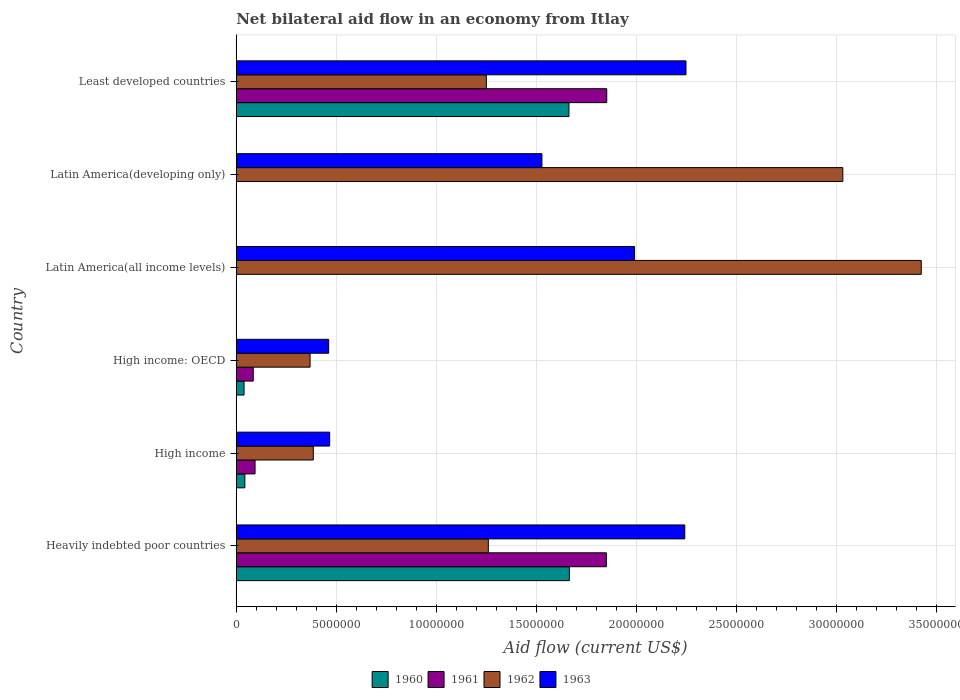Are the number of bars on each tick of the Y-axis equal?
Your response must be concise. No. How many bars are there on the 3rd tick from the top?
Your answer should be very brief. 2. How many bars are there on the 3rd tick from the bottom?
Your response must be concise. 4. What is the label of the 1st group of bars from the top?
Keep it short and to the point. Least developed countries. In how many cases, is the number of bars for a given country not equal to the number of legend labels?
Your answer should be compact. 2. What is the net bilateral aid flow in 1962 in Heavily indebted poor countries?
Offer a very short reply. 1.26e+07. Across all countries, what is the maximum net bilateral aid flow in 1963?
Your answer should be very brief. 2.25e+07. In which country was the net bilateral aid flow in 1963 maximum?
Provide a short and direct response. Least developed countries. What is the total net bilateral aid flow in 1960 in the graph?
Ensure brevity in your answer.  3.41e+07. What is the difference between the net bilateral aid flow in 1962 in High income: OECD and that in Latin America(all income levels)?
Your answer should be very brief. -3.06e+07. What is the difference between the net bilateral aid flow in 1961 in High income and the net bilateral aid flow in 1960 in Latin America(developing only)?
Ensure brevity in your answer.  9.40e+05. What is the average net bilateral aid flow in 1961 per country?
Provide a succinct answer. 6.47e+06. What is the difference between the net bilateral aid flow in 1962 and net bilateral aid flow in 1960 in High income: OECD?
Ensure brevity in your answer.  3.30e+06. In how many countries, is the net bilateral aid flow in 1961 greater than 14000000 US$?
Ensure brevity in your answer.  2. What is the ratio of the net bilateral aid flow in 1963 in Heavily indebted poor countries to that in Least developed countries?
Your answer should be compact. 1. Is the net bilateral aid flow in 1962 in Latin America(all income levels) less than that in Least developed countries?
Ensure brevity in your answer.  No. What is the difference between the highest and the lowest net bilateral aid flow in 1960?
Keep it short and to the point. 1.66e+07. In how many countries, is the net bilateral aid flow in 1962 greater than the average net bilateral aid flow in 1962 taken over all countries?
Make the answer very short. 2. Is it the case that in every country, the sum of the net bilateral aid flow in 1962 and net bilateral aid flow in 1961 is greater than the sum of net bilateral aid flow in 1963 and net bilateral aid flow in 1960?
Keep it short and to the point. No. Does the graph contain grids?
Make the answer very short. Yes. How many legend labels are there?
Provide a short and direct response. 4. What is the title of the graph?
Make the answer very short. Net bilateral aid flow in an economy from Itlay. What is the Aid flow (current US$) of 1960 in Heavily indebted poor countries?
Offer a very short reply. 1.66e+07. What is the Aid flow (current US$) of 1961 in Heavily indebted poor countries?
Provide a short and direct response. 1.85e+07. What is the Aid flow (current US$) in 1962 in Heavily indebted poor countries?
Offer a terse response. 1.26e+07. What is the Aid flow (current US$) in 1963 in Heavily indebted poor countries?
Provide a short and direct response. 2.24e+07. What is the Aid flow (current US$) in 1961 in High income?
Provide a short and direct response. 9.40e+05. What is the Aid flow (current US$) of 1962 in High income?
Your answer should be compact. 3.85e+06. What is the Aid flow (current US$) of 1963 in High income?
Your response must be concise. 4.67e+06. What is the Aid flow (current US$) of 1960 in High income: OECD?
Ensure brevity in your answer.  3.90e+05. What is the Aid flow (current US$) in 1961 in High income: OECD?
Offer a very short reply. 8.50e+05. What is the Aid flow (current US$) in 1962 in High income: OECD?
Keep it short and to the point. 3.69e+06. What is the Aid flow (current US$) of 1963 in High income: OECD?
Provide a succinct answer. 4.62e+06. What is the Aid flow (current US$) of 1960 in Latin America(all income levels)?
Provide a succinct answer. 0. What is the Aid flow (current US$) of 1961 in Latin America(all income levels)?
Provide a short and direct response. 0. What is the Aid flow (current US$) of 1962 in Latin America(all income levels)?
Provide a succinct answer. 3.42e+07. What is the Aid flow (current US$) in 1963 in Latin America(all income levels)?
Offer a terse response. 1.99e+07. What is the Aid flow (current US$) of 1962 in Latin America(developing only)?
Keep it short and to the point. 3.03e+07. What is the Aid flow (current US$) in 1963 in Latin America(developing only)?
Your answer should be very brief. 1.53e+07. What is the Aid flow (current US$) of 1960 in Least developed countries?
Your response must be concise. 1.66e+07. What is the Aid flow (current US$) in 1961 in Least developed countries?
Give a very brief answer. 1.85e+07. What is the Aid flow (current US$) of 1962 in Least developed countries?
Your response must be concise. 1.25e+07. What is the Aid flow (current US$) of 1963 in Least developed countries?
Ensure brevity in your answer.  2.25e+07. Across all countries, what is the maximum Aid flow (current US$) of 1960?
Offer a very short reply. 1.66e+07. Across all countries, what is the maximum Aid flow (current US$) in 1961?
Offer a terse response. 1.85e+07. Across all countries, what is the maximum Aid flow (current US$) of 1962?
Your response must be concise. 3.42e+07. Across all countries, what is the maximum Aid flow (current US$) of 1963?
Your answer should be compact. 2.25e+07. Across all countries, what is the minimum Aid flow (current US$) of 1960?
Provide a short and direct response. 0. Across all countries, what is the minimum Aid flow (current US$) of 1961?
Offer a very short reply. 0. Across all countries, what is the minimum Aid flow (current US$) of 1962?
Provide a short and direct response. 3.69e+06. Across all countries, what is the minimum Aid flow (current US$) of 1963?
Provide a short and direct response. 4.62e+06. What is the total Aid flow (current US$) of 1960 in the graph?
Your answer should be compact. 3.41e+07. What is the total Aid flow (current US$) of 1961 in the graph?
Offer a very short reply. 3.88e+07. What is the total Aid flow (current US$) in 1962 in the graph?
Offer a terse response. 9.72e+07. What is the total Aid flow (current US$) in 1963 in the graph?
Offer a terse response. 8.94e+07. What is the difference between the Aid flow (current US$) of 1960 in Heavily indebted poor countries and that in High income?
Provide a short and direct response. 1.62e+07. What is the difference between the Aid flow (current US$) of 1961 in Heavily indebted poor countries and that in High income?
Keep it short and to the point. 1.76e+07. What is the difference between the Aid flow (current US$) in 1962 in Heavily indebted poor countries and that in High income?
Your answer should be compact. 8.75e+06. What is the difference between the Aid flow (current US$) of 1963 in Heavily indebted poor countries and that in High income?
Give a very brief answer. 1.78e+07. What is the difference between the Aid flow (current US$) of 1960 in Heavily indebted poor countries and that in High income: OECD?
Provide a succinct answer. 1.63e+07. What is the difference between the Aid flow (current US$) of 1961 in Heavily indebted poor countries and that in High income: OECD?
Ensure brevity in your answer.  1.76e+07. What is the difference between the Aid flow (current US$) in 1962 in Heavily indebted poor countries and that in High income: OECD?
Your answer should be very brief. 8.91e+06. What is the difference between the Aid flow (current US$) in 1963 in Heavily indebted poor countries and that in High income: OECD?
Your response must be concise. 1.78e+07. What is the difference between the Aid flow (current US$) of 1962 in Heavily indebted poor countries and that in Latin America(all income levels)?
Make the answer very short. -2.16e+07. What is the difference between the Aid flow (current US$) of 1963 in Heavily indebted poor countries and that in Latin America(all income levels)?
Ensure brevity in your answer.  2.51e+06. What is the difference between the Aid flow (current US$) in 1962 in Heavily indebted poor countries and that in Latin America(developing only)?
Ensure brevity in your answer.  -1.77e+07. What is the difference between the Aid flow (current US$) of 1963 in Heavily indebted poor countries and that in Latin America(developing only)?
Your answer should be very brief. 7.14e+06. What is the difference between the Aid flow (current US$) in 1960 in Heavily indebted poor countries and that in Least developed countries?
Offer a terse response. 2.00e+04. What is the difference between the Aid flow (current US$) in 1961 in Heavily indebted poor countries and that in Least developed countries?
Provide a short and direct response. -2.00e+04. What is the difference between the Aid flow (current US$) in 1962 in Heavily indebted poor countries and that in Least developed countries?
Offer a very short reply. 1.00e+05. What is the difference between the Aid flow (current US$) in 1963 in Heavily indebted poor countries and that in Least developed countries?
Your answer should be very brief. -6.00e+04. What is the difference between the Aid flow (current US$) in 1960 in High income and that in High income: OECD?
Make the answer very short. 4.00e+04. What is the difference between the Aid flow (current US$) of 1961 in High income and that in High income: OECD?
Offer a terse response. 9.00e+04. What is the difference between the Aid flow (current US$) of 1963 in High income and that in High income: OECD?
Keep it short and to the point. 5.00e+04. What is the difference between the Aid flow (current US$) of 1962 in High income and that in Latin America(all income levels)?
Offer a terse response. -3.04e+07. What is the difference between the Aid flow (current US$) of 1963 in High income and that in Latin America(all income levels)?
Ensure brevity in your answer.  -1.52e+07. What is the difference between the Aid flow (current US$) in 1962 in High income and that in Latin America(developing only)?
Your answer should be very brief. -2.65e+07. What is the difference between the Aid flow (current US$) in 1963 in High income and that in Latin America(developing only)?
Keep it short and to the point. -1.06e+07. What is the difference between the Aid flow (current US$) in 1960 in High income and that in Least developed countries?
Provide a succinct answer. -1.62e+07. What is the difference between the Aid flow (current US$) in 1961 in High income and that in Least developed countries?
Offer a very short reply. -1.76e+07. What is the difference between the Aid flow (current US$) of 1962 in High income and that in Least developed countries?
Ensure brevity in your answer.  -8.65e+06. What is the difference between the Aid flow (current US$) in 1963 in High income and that in Least developed countries?
Provide a succinct answer. -1.78e+07. What is the difference between the Aid flow (current US$) in 1962 in High income: OECD and that in Latin America(all income levels)?
Make the answer very short. -3.06e+07. What is the difference between the Aid flow (current US$) in 1963 in High income: OECD and that in Latin America(all income levels)?
Ensure brevity in your answer.  -1.53e+07. What is the difference between the Aid flow (current US$) in 1962 in High income: OECD and that in Latin America(developing only)?
Offer a very short reply. -2.66e+07. What is the difference between the Aid flow (current US$) in 1963 in High income: OECD and that in Latin America(developing only)?
Ensure brevity in your answer.  -1.07e+07. What is the difference between the Aid flow (current US$) of 1960 in High income: OECD and that in Least developed countries?
Ensure brevity in your answer.  -1.62e+07. What is the difference between the Aid flow (current US$) in 1961 in High income: OECD and that in Least developed countries?
Offer a very short reply. -1.77e+07. What is the difference between the Aid flow (current US$) in 1962 in High income: OECD and that in Least developed countries?
Provide a succinct answer. -8.81e+06. What is the difference between the Aid flow (current US$) in 1963 in High income: OECD and that in Least developed countries?
Provide a succinct answer. -1.79e+07. What is the difference between the Aid flow (current US$) of 1962 in Latin America(all income levels) and that in Latin America(developing only)?
Provide a short and direct response. 3.92e+06. What is the difference between the Aid flow (current US$) in 1963 in Latin America(all income levels) and that in Latin America(developing only)?
Offer a terse response. 4.63e+06. What is the difference between the Aid flow (current US$) of 1962 in Latin America(all income levels) and that in Least developed countries?
Provide a succinct answer. 2.17e+07. What is the difference between the Aid flow (current US$) in 1963 in Latin America(all income levels) and that in Least developed countries?
Your answer should be compact. -2.57e+06. What is the difference between the Aid flow (current US$) in 1962 in Latin America(developing only) and that in Least developed countries?
Make the answer very short. 1.78e+07. What is the difference between the Aid flow (current US$) of 1963 in Latin America(developing only) and that in Least developed countries?
Provide a succinct answer. -7.20e+06. What is the difference between the Aid flow (current US$) in 1960 in Heavily indebted poor countries and the Aid flow (current US$) in 1961 in High income?
Offer a terse response. 1.57e+07. What is the difference between the Aid flow (current US$) in 1960 in Heavily indebted poor countries and the Aid flow (current US$) in 1962 in High income?
Your response must be concise. 1.28e+07. What is the difference between the Aid flow (current US$) in 1960 in Heavily indebted poor countries and the Aid flow (current US$) in 1963 in High income?
Make the answer very short. 1.20e+07. What is the difference between the Aid flow (current US$) in 1961 in Heavily indebted poor countries and the Aid flow (current US$) in 1962 in High income?
Give a very brief answer. 1.46e+07. What is the difference between the Aid flow (current US$) of 1961 in Heavily indebted poor countries and the Aid flow (current US$) of 1963 in High income?
Make the answer very short. 1.38e+07. What is the difference between the Aid flow (current US$) of 1962 in Heavily indebted poor countries and the Aid flow (current US$) of 1963 in High income?
Give a very brief answer. 7.93e+06. What is the difference between the Aid flow (current US$) of 1960 in Heavily indebted poor countries and the Aid flow (current US$) of 1961 in High income: OECD?
Make the answer very short. 1.58e+07. What is the difference between the Aid flow (current US$) of 1960 in Heavily indebted poor countries and the Aid flow (current US$) of 1962 in High income: OECD?
Your answer should be compact. 1.30e+07. What is the difference between the Aid flow (current US$) in 1960 in Heavily indebted poor countries and the Aid flow (current US$) in 1963 in High income: OECD?
Provide a short and direct response. 1.20e+07. What is the difference between the Aid flow (current US$) of 1961 in Heavily indebted poor countries and the Aid flow (current US$) of 1962 in High income: OECD?
Give a very brief answer. 1.48e+07. What is the difference between the Aid flow (current US$) of 1961 in Heavily indebted poor countries and the Aid flow (current US$) of 1963 in High income: OECD?
Your answer should be very brief. 1.39e+07. What is the difference between the Aid flow (current US$) of 1962 in Heavily indebted poor countries and the Aid flow (current US$) of 1963 in High income: OECD?
Offer a very short reply. 7.98e+06. What is the difference between the Aid flow (current US$) in 1960 in Heavily indebted poor countries and the Aid flow (current US$) in 1962 in Latin America(all income levels)?
Offer a terse response. -1.76e+07. What is the difference between the Aid flow (current US$) of 1960 in Heavily indebted poor countries and the Aid flow (current US$) of 1963 in Latin America(all income levels)?
Provide a succinct answer. -3.26e+06. What is the difference between the Aid flow (current US$) of 1961 in Heavily indebted poor countries and the Aid flow (current US$) of 1962 in Latin America(all income levels)?
Ensure brevity in your answer.  -1.57e+07. What is the difference between the Aid flow (current US$) in 1961 in Heavily indebted poor countries and the Aid flow (current US$) in 1963 in Latin America(all income levels)?
Keep it short and to the point. -1.41e+06. What is the difference between the Aid flow (current US$) of 1962 in Heavily indebted poor countries and the Aid flow (current US$) of 1963 in Latin America(all income levels)?
Your answer should be compact. -7.31e+06. What is the difference between the Aid flow (current US$) of 1960 in Heavily indebted poor countries and the Aid flow (current US$) of 1962 in Latin America(developing only)?
Your response must be concise. -1.37e+07. What is the difference between the Aid flow (current US$) in 1960 in Heavily indebted poor countries and the Aid flow (current US$) in 1963 in Latin America(developing only)?
Make the answer very short. 1.37e+06. What is the difference between the Aid flow (current US$) of 1961 in Heavily indebted poor countries and the Aid flow (current US$) of 1962 in Latin America(developing only)?
Make the answer very short. -1.18e+07. What is the difference between the Aid flow (current US$) of 1961 in Heavily indebted poor countries and the Aid flow (current US$) of 1963 in Latin America(developing only)?
Your response must be concise. 3.22e+06. What is the difference between the Aid flow (current US$) in 1962 in Heavily indebted poor countries and the Aid flow (current US$) in 1963 in Latin America(developing only)?
Keep it short and to the point. -2.68e+06. What is the difference between the Aid flow (current US$) in 1960 in Heavily indebted poor countries and the Aid flow (current US$) in 1961 in Least developed countries?
Ensure brevity in your answer.  -1.87e+06. What is the difference between the Aid flow (current US$) of 1960 in Heavily indebted poor countries and the Aid flow (current US$) of 1962 in Least developed countries?
Give a very brief answer. 4.15e+06. What is the difference between the Aid flow (current US$) of 1960 in Heavily indebted poor countries and the Aid flow (current US$) of 1963 in Least developed countries?
Your answer should be very brief. -5.83e+06. What is the difference between the Aid flow (current US$) in 1961 in Heavily indebted poor countries and the Aid flow (current US$) in 1962 in Least developed countries?
Provide a succinct answer. 6.00e+06. What is the difference between the Aid flow (current US$) in 1961 in Heavily indebted poor countries and the Aid flow (current US$) in 1963 in Least developed countries?
Provide a succinct answer. -3.98e+06. What is the difference between the Aid flow (current US$) of 1962 in Heavily indebted poor countries and the Aid flow (current US$) of 1963 in Least developed countries?
Provide a short and direct response. -9.88e+06. What is the difference between the Aid flow (current US$) of 1960 in High income and the Aid flow (current US$) of 1961 in High income: OECD?
Provide a succinct answer. -4.20e+05. What is the difference between the Aid flow (current US$) of 1960 in High income and the Aid flow (current US$) of 1962 in High income: OECD?
Keep it short and to the point. -3.26e+06. What is the difference between the Aid flow (current US$) of 1960 in High income and the Aid flow (current US$) of 1963 in High income: OECD?
Give a very brief answer. -4.19e+06. What is the difference between the Aid flow (current US$) of 1961 in High income and the Aid flow (current US$) of 1962 in High income: OECD?
Your answer should be very brief. -2.75e+06. What is the difference between the Aid flow (current US$) in 1961 in High income and the Aid flow (current US$) in 1963 in High income: OECD?
Give a very brief answer. -3.68e+06. What is the difference between the Aid flow (current US$) of 1962 in High income and the Aid flow (current US$) of 1963 in High income: OECD?
Offer a terse response. -7.70e+05. What is the difference between the Aid flow (current US$) of 1960 in High income and the Aid flow (current US$) of 1962 in Latin America(all income levels)?
Provide a short and direct response. -3.38e+07. What is the difference between the Aid flow (current US$) in 1960 in High income and the Aid flow (current US$) in 1963 in Latin America(all income levels)?
Provide a short and direct response. -1.95e+07. What is the difference between the Aid flow (current US$) of 1961 in High income and the Aid flow (current US$) of 1962 in Latin America(all income levels)?
Provide a succinct answer. -3.33e+07. What is the difference between the Aid flow (current US$) in 1961 in High income and the Aid flow (current US$) in 1963 in Latin America(all income levels)?
Provide a succinct answer. -1.90e+07. What is the difference between the Aid flow (current US$) of 1962 in High income and the Aid flow (current US$) of 1963 in Latin America(all income levels)?
Provide a succinct answer. -1.61e+07. What is the difference between the Aid flow (current US$) of 1960 in High income and the Aid flow (current US$) of 1962 in Latin America(developing only)?
Provide a succinct answer. -2.99e+07. What is the difference between the Aid flow (current US$) of 1960 in High income and the Aid flow (current US$) of 1963 in Latin America(developing only)?
Offer a terse response. -1.48e+07. What is the difference between the Aid flow (current US$) in 1961 in High income and the Aid flow (current US$) in 1962 in Latin America(developing only)?
Give a very brief answer. -2.94e+07. What is the difference between the Aid flow (current US$) in 1961 in High income and the Aid flow (current US$) in 1963 in Latin America(developing only)?
Provide a short and direct response. -1.43e+07. What is the difference between the Aid flow (current US$) in 1962 in High income and the Aid flow (current US$) in 1963 in Latin America(developing only)?
Your answer should be compact. -1.14e+07. What is the difference between the Aid flow (current US$) in 1960 in High income and the Aid flow (current US$) in 1961 in Least developed countries?
Ensure brevity in your answer.  -1.81e+07. What is the difference between the Aid flow (current US$) of 1960 in High income and the Aid flow (current US$) of 1962 in Least developed countries?
Give a very brief answer. -1.21e+07. What is the difference between the Aid flow (current US$) of 1960 in High income and the Aid flow (current US$) of 1963 in Least developed countries?
Give a very brief answer. -2.20e+07. What is the difference between the Aid flow (current US$) in 1961 in High income and the Aid flow (current US$) in 1962 in Least developed countries?
Offer a terse response. -1.16e+07. What is the difference between the Aid flow (current US$) in 1961 in High income and the Aid flow (current US$) in 1963 in Least developed countries?
Your answer should be very brief. -2.15e+07. What is the difference between the Aid flow (current US$) of 1962 in High income and the Aid flow (current US$) of 1963 in Least developed countries?
Give a very brief answer. -1.86e+07. What is the difference between the Aid flow (current US$) in 1960 in High income: OECD and the Aid flow (current US$) in 1962 in Latin America(all income levels)?
Provide a short and direct response. -3.38e+07. What is the difference between the Aid flow (current US$) of 1960 in High income: OECD and the Aid flow (current US$) of 1963 in Latin America(all income levels)?
Make the answer very short. -1.95e+07. What is the difference between the Aid flow (current US$) in 1961 in High income: OECD and the Aid flow (current US$) in 1962 in Latin America(all income levels)?
Your answer should be compact. -3.34e+07. What is the difference between the Aid flow (current US$) of 1961 in High income: OECD and the Aid flow (current US$) of 1963 in Latin America(all income levels)?
Give a very brief answer. -1.91e+07. What is the difference between the Aid flow (current US$) in 1962 in High income: OECD and the Aid flow (current US$) in 1963 in Latin America(all income levels)?
Keep it short and to the point. -1.62e+07. What is the difference between the Aid flow (current US$) in 1960 in High income: OECD and the Aid flow (current US$) in 1962 in Latin America(developing only)?
Provide a short and direct response. -2.99e+07. What is the difference between the Aid flow (current US$) of 1960 in High income: OECD and the Aid flow (current US$) of 1963 in Latin America(developing only)?
Provide a succinct answer. -1.49e+07. What is the difference between the Aid flow (current US$) in 1961 in High income: OECD and the Aid flow (current US$) in 1962 in Latin America(developing only)?
Provide a short and direct response. -2.95e+07. What is the difference between the Aid flow (current US$) in 1961 in High income: OECD and the Aid flow (current US$) in 1963 in Latin America(developing only)?
Provide a short and direct response. -1.44e+07. What is the difference between the Aid flow (current US$) in 1962 in High income: OECD and the Aid flow (current US$) in 1963 in Latin America(developing only)?
Ensure brevity in your answer.  -1.16e+07. What is the difference between the Aid flow (current US$) of 1960 in High income: OECD and the Aid flow (current US$) of 1961 in Least developed countries?
Your answer should be compact. -1.81e+07. What is the difference between the Aid flow (current US$) in 1960 in High income: OECD and the Aid flow (current US$) in 1962 in Least developed countries?
Offer a very short reply. -1.21e+07. What is the difference between the Aid flow (current US$) of 1960 in High income: OECD and the Aid flow (current US$) of 1963 in Least developed countries?
Give a very brief answer. -2.21e+07. What is the difference between the Aid flow (current US$) of 1961 in High income: OECD and the Aid flow (current US$) of 1962 in Least developed countries?
Provide a succinct answer. -1.16e+07. What is the difference between the Aid flow (current US$) in 1961 in High income: OECD and the Aid flow (current US$) in 1963 in Least developed countries?
Offer a very short reply. -2.16e+07. What is the difference between the Aid flow (current US$) of 1962 in High income: OECD and the Aid flow (current US$) of 1963 in Least developed countries?
Make the answer very short. -1.88e+07. What is the difference between the Aid flow (current US$) of 1962 in Latin America(all income levels) and the Aid flow (current US$) of 1963 in Latin America(developing only)?
Provide a short and direct response. 1.90e+07. What is the difference between the Aid flow (current US$) in 1962 in Latin America(all income levels) and the Aid flow (current US$) in 1963 in Least developed countries?
Your answer should be very brief. 1.18e+07. What is the difference between the Aid flow (current US$) in 1962 in Latin America(developing only) and the Aid flow (current US$) in 1963 in Least developed countries?
Your response must be concise. 7.84e+06. What is the average Aid flow (current US$) of 1960 per country?
Your answer should be very brief. 5.68e+06. What is the average Aid flow (current US$) in 1961 per country?
Your response must be concise. 6.47e+06. What is the average Aid flow (current US$) in 1962 per country?
Your answer should be compact. 1.62e+07. What is the average Aid flow (current US$) in 1963 per country?
Provide a succinct answer. 1.49e+07. What is the difference between the Aid flow (current US$) of 1960 and Aid flow (current US$) of 1961 in Heavily indebted poor countries?
Ensure brevity in your answer.  -1.85e+06. What is the difference between the Aid flow (current US$) of 1960 and Aid flow (current US$) of 1962 in Heavily indebted poor countries?
Offer a very short reply. 4.05e+06. What is the difference between the Aid flow (current US$) in 1960 and Aid flow (current US$) in 1963 in Heavily indebted poor countries?
Offer a very short reply. -5.77e+06. What is the difference between the Aid flow (current US$) in 1961 and Aid flow (current US$) in 1962 in Heavily indebted poor countries?
Offer a very short reply. 5.90e+06. What is the difference between the Aid flow (current US$) in 1961 and Aid flow (current US$) in 1963 in Heavily indebted poor countries?
Provide a succinct answer. -3.92e+06. What is the difference between the Aid flow (current US$) in 1962 and Aid flow (current US$) in 1963 in Heavily indebted poor countries?
Provide a short and direct response. -9.82e+06. What is the difference between the Aid flow (current US$) in 1960 and Aid flow (current US$) in 1961 in High income?
Provide a succinct answer. -5.10e+05. What is the difference between the Aid flow (current US$) in 1960 and Aid flow (current US$) in 1962 in High income?
Offer a terse response. -3.42e+06. What is the difference between the Aid flow (current US$) of 1960 and Aid flow (current US$) of 1963 in High income?
Give a very brief answer. -4.24e+06. What is the difference between the Aid flow (current US$) of 1961 and Aid flow (current US$) of 1962 in High income?
Offer a terse response. -2.91e+06. What is the difference between the Aid flow (current US$) of 1961 and Aid flow (current US$) of 1963 in High income?
Offer a terse response. -3.73e+06. What is the difference between the Aid flow (current US$) in 1962 and Aid flow (current US$) in 1963 in High income?
Keep it short and to the point. -8.20e+05. What is the difference between the Aid flow (current US$) in 1960 and Aid flow (current US$) in 1961 in High income: OECD?
Provide a short and direct response. -4.60e+05. What is the difference between the Aid flow (current US$) in 1960 and Aid flow (current US$) in 1962 in High income: OECD?
Your answer should be compact. -3.30e+06. What is the difference between the Aid flow (current US$) of 1960 and Aid flow (current US$) of 1963 in High income: OECD?
Offer a terse response. -4.23e+06. What is the difference between the Aid flow (current US$) in 1961 and Aid flow (current US$) in 1962 in High income: OECD?
Your answer should be compact. -2.84e+06. What is the difference between the Aid flow (current US$) in 1961 and Aid flow (current US$) in 1963 in High income: OECD?
Make the answer very short. -3.77e+06. What is the difference between the Aid flow (current US$) of 1962 and Aid flow (current US$) of 1963 in High income: OECD?
Make the answer very short. -9.30e+05. What is the difference between the Aid flow (current US$) of 1962 and Aid flow (current US$) of 1963 in Latin America(all income levels)?
Your answer should be compact. 1.43e+07. What is the difference between the Aid flow (current US$) in 1962 and Aid flow (current US$) in 1963 in Latin America(developing only)?
Your answer should be compact. 1.50e+07. What is the difference between the Aid flow (current US$) of 1960 and Aid flow (current US$) of 1961 in Least developed countries?
Give a very brief answer. -1.89e+06. What is the difference between the Aid flow (current US$) of 1960 and Aid flow (current US$) of 1962 in Least developed countries?
Keep it short and to the point. 4.13e+06. What is the difference between the Aid flow (current US$) in 1960 and Aid flow (current US$) in 1963 in Least developed countries?
Make the answer very short. -5.85e+06. What is the difference between the Aid flow (current US$) in 1961 and Aid flow (current US$) in 1962 in Least developed countries?
Offer a terse response. 6.02e+06. What is the difference between the Aid flow (current US$) of 1961 and Aid flow (current US$) of 1963 in Least developed countries?
Offer a terse response. -3.96e+06. What is the difference between the Aid flow (current US$) of 1962 and Aid flow (current US$) of 1963 in Least developed countries?
Your answer should be very brief. -9.98e+06. What is the ratio of the Aid flow (current US$) of 1960 in Heavily indebted poor countries to that in High income?
Make the answer very short. 38.72. What is the ratio of the Aid flow (current US$) of 1961 in Heavily indebted poor countries to that in High income?
Your response must be concise. 19.68. What is the ratio of the Aid flow (current US$) of 1962 in Heavily indebted poor countries to that in High income?
Offer a terse response. 3.27. What is the ratio of the Aid flow (current US$) in 1963 in Heavily indebted poor countries to that in High income?
Your answer should be compact. 4.8. What is the ratio of the Aid flow (current US$) of 1960 in Heavily indebted poor countries to that in High income: OECD?
Give a very brief answer. 42.69. What is the ratio of the Aid flow (current US$) in 1961 in Heavily indebted poor countries to that in High income: OECD?
Make the answer very short. 21.76. What is the ratio of the Aid flow (current US$) in 1962 in Heavily indebted poor countries to that in High income: OECD?
Offer a terse response. 3.41. What is the ratio of the Aid flow (current US$) in 1963 in Heavily indebted poor countries to that in High income: OECD?
Offer a terse response. 4.85. What is the ratio of the Aid flow (current US$) of 1962 in Heavily indebted poor countries to that in Latin America(all income levels)?
Offer a very short reply. 0.37. What is the ratio of the Aid flow (current US$) of 1963 in Heavily indebted poor countries to that in Latin America(all income levels)?
Give a very brief answer. 1.13. What is the ratio of the Aid flow (current US$) in 1962 in Heavily indebted poor countries to that in Latin America(developing only)?
Keep it short and to the point. 0.42. What is the ratio of the Aid flow (current US$) of 1963 in Heavily indebted poor countries to that in Latin America(developing only)?
Your response must be concise. 1.47. What is the ratio of the Aid flow (current US$) of 1960 in Heavily indebted poor countries to that in Least developed countries?
Provide a succinct answer. 1. What is the ratio of the Aid flow (current US$) of 1962 in Heavily indebted poor countries to that in Least developed countries?
Your answer should be compact. 1.01. What is the ratio of the Aid flow (current US$) of 1960 in High income to that in High income: OECD?
Offer a terse response. 1.1. What is the ratio of the Aid flow (current US$) of 1961 in High income to that in High income: OECD?
Provide a short and direct response. 1.11. What is the ratio of the Aid flow (current US$) of 1962 in High income to that in High income: OECD?
Provide a succinct answer. 1.04. What is the ratio of the Aid flow (current US$) in 1963 in High income to that in High income: OECD?
Ensure brevity in your answer.  1.01. What is the ratio of the Aid flow (current US$) of 1962 in High income to that in Latin America(all income levels)?
Make the answer very short. 0.11. What is the ratio of the Aid flow (current US$) in 1963 in High income to that in Latin America(all income levels)?
Make the answer very short. 0.23. What is the ratio of the Aid flow (current US$) of 1962 in High income to that in Latin America(developing only)?
Keep it short and to the point. 0.13. What is the ratio of the Aid flow (current US$) of 1963 in High income to that in Latin America(developing only)?
Keep it short and to the point. 0.31. What is the ratio of the Aid flow (current US$) in 1960 in High income to that in Least developed countries?
Make the answer very short. 0.03. What is the ratio of the Aid flow (current US$) of 1961 in High income to that in Least developed countries?
Offer a very short reply. 0.05. What is the ratio of the Aid flow (current US$) of 1962 in High income to that in Least developed countries?
Keep it short and to the point. 0.31. What is the ratio of the Aid flow (current US$) of 1963 in High income to that in Least developed countries?
Your answer should be compact. 0.21. What is the ratio of the Aid flow (current US$) in 1962 in High income: OECD to that in Latin America(all income levels)?
Ensure brevity in your answer.  0.11. What is the ratio of the Aid flow (current US$) in 1963 in High income: OECD to that in Latin America(all income levels)?
Make the answer very short. 0.23. What is the ratio of the Aid flow (current US$) of 1962 in High income: OECD to that in Latin America(developing only)?
Provide a succinct answer. 0.12. What is the ratio of the Aid flow (current US$) in 1963 in High income: OECD to that in Latin America(developing only)?
Provide a succinct answer. 0.3. What is the ratio of the Aid flow (current US$) of 1960 in High income: OECD to that in Least developed countries?
Provide a succinct answer. 0.02. What is the ratio of the Aid flow (current US$) in 1961 in High income: OECD to that in Least developed countries?
Ensure brevity in your answer.  0.05. What is the ratio of the Aid flow (current US$) of 1962 in High income: OECD to that in Least developed countries?
Your answer should be compact. 0.3. What is the ratio of the Aid flow (current US$) in 1963 in High income: OECD to that in Least developed countries?
Give a very brief answer. 0.21. What is the ratio of the Aid flow (current US$) in 1962 in Latin America(all income levels) to that in Latin America(developing only)?
Your answer should be very brief. 1.13. What is the ratio of the Aid flow (current US$) of 1963 in Latin America(all income levels) to that in Latin America(developing only)?
Provide a succinct answer. 1.3. What is the ratio of the Aid flow (current US$) of 1962 in Latin America(all income levels) to that in Least developed countries?
Keep it short and to the point. 2.74. What is the ratio of the Aid flow (current US$) of 1963 in Latin America(all income levels) to that in Least developed countries?
Keep it short and to the point. 0.89. What is the ratio of the Aid flow (current US$) in 1962 in Latin America(developing only) to that in Least developed countries?
Offer a terse response. 2.43. What is the ratio of the Aid flow (current US$) of 1963 in Latin America(developing only) to that in Least developed countries?
Your answer should be compact. 0.68. What is the difference between the highest and the second highest Aid flow (current US$) of 1962?
Keep it short and to the point. 3.92e+06. What is the difference between the highest and the second highest Aid flow (current US$) of 1963?
Give a very brief answer. 6.00e+04. What is the difference between the highest and the lowest Aid flow (current US$) in 1960?
Your answer should be compact. 1.66e+07. What is the difference between the highest and the lowest Aid flow (current US$) in 1961?
Make the answer very short. 1.85e+07. What is the difference between the highest and the lowest Aid flow (current US$) of 1962?
Ensure brevity in your answer.  3.06e+07. What is the difference between the highest and the lowest Aid flow (current US$) in 1963?
Make the answer very short. 1.79e+07. 